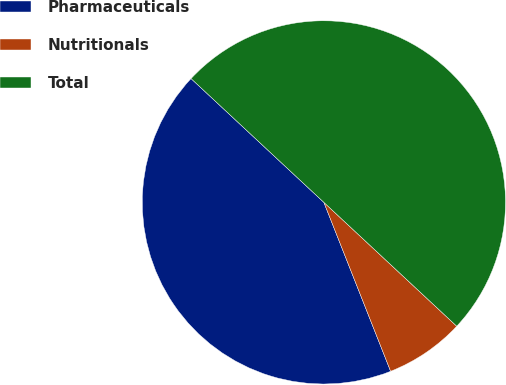Convert chart. <chart><loc_0><loc_0><loc_500><loc_500><pie_chart><fcel>Pharmaceuticals<fcel>Nutritionals<fcel>Total<nl><fcel>42.93%<fcel>7.07%<fcel>50.0%<nl></chart> 